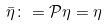Convert formula to latex. <formula><loc_0><loc_0><loc_500><loc_500>\bar { \eta } \colon = \mathcal { P } \eta = \eta</formula> 